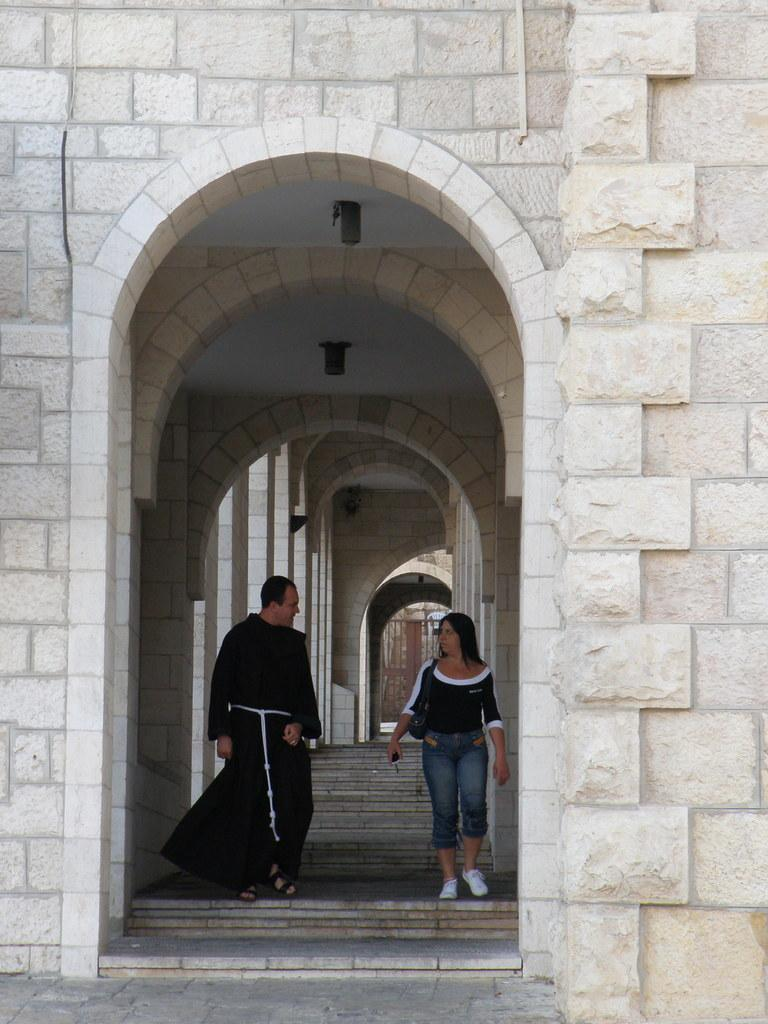Where was the picture taken? The picture was taken outside. What can be seen in the center of the image? There is a wall of a building in the center of the image. What architectural feature of the building is visible? There are multiple arches of the building visible. What are the two persons in the image doing? Two persons are walking on the ground in the image. What type of record is being played by the person in the image? There is no person playing a record in the image; it only shows two persons walking on the ground. What color is the flag flying above the building in the image? There is no flag visible in the image; it only shows the wall of a building and multiple arches. 